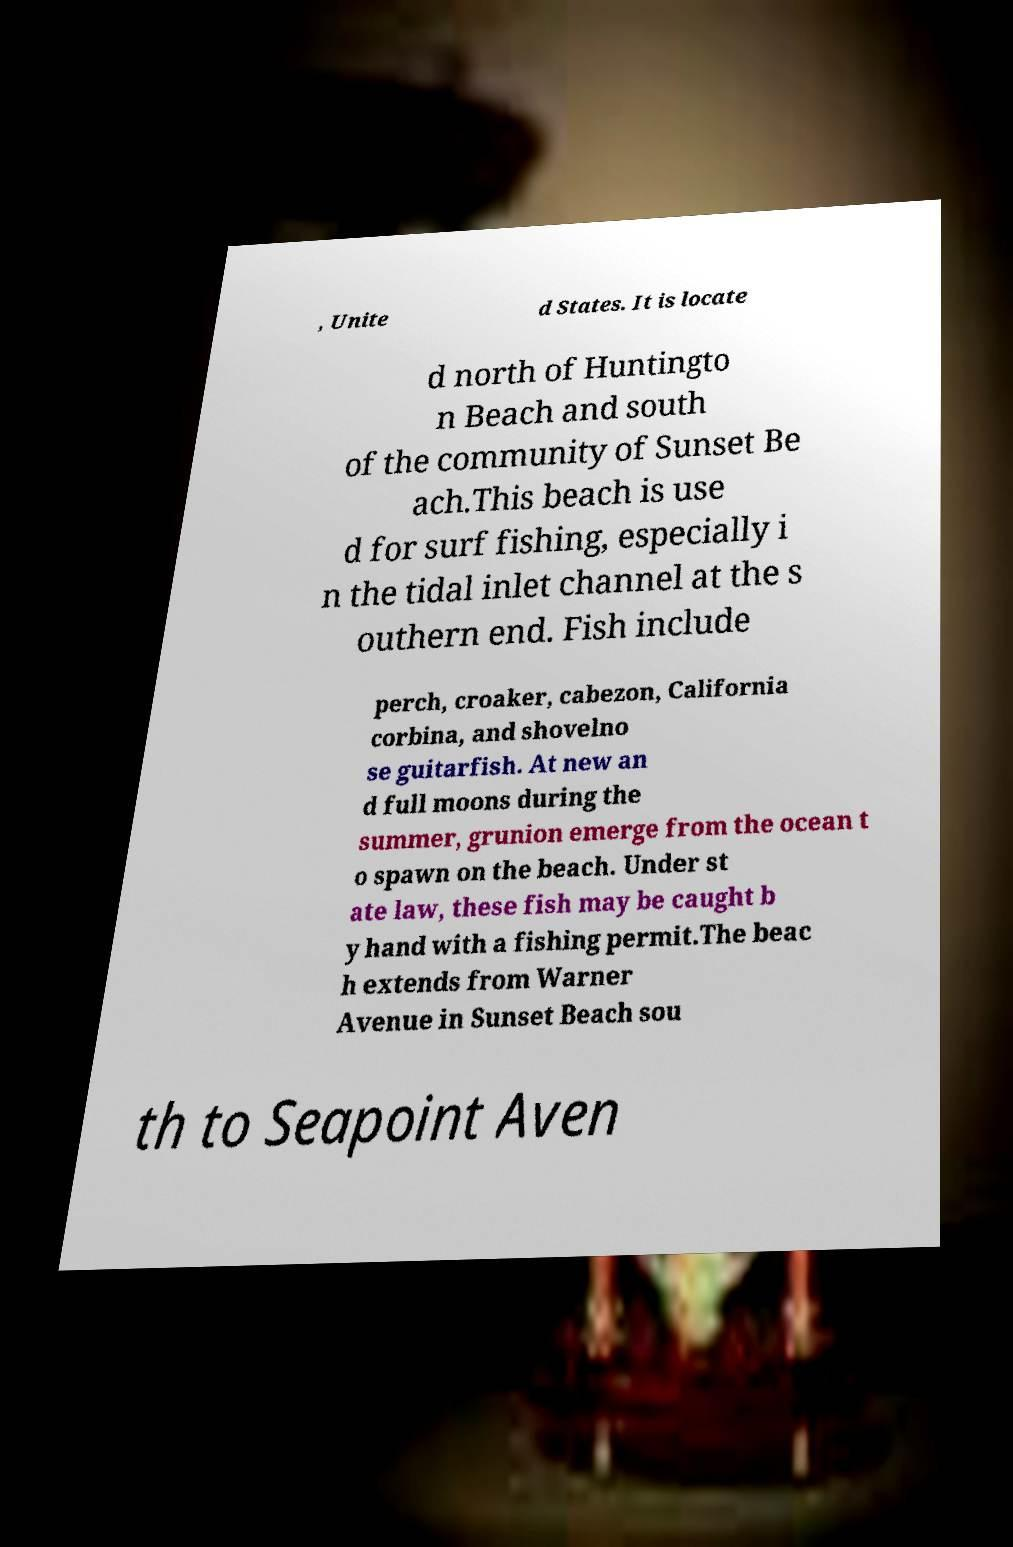There's text embedded in this image that I need extracted. Can you transcribe it verbatim? , Unite d States. It is locate d north of Huntingto n Beach and south of the community of Sunset Be ach.This beach is use d for surf fishing, especially i n the tidal inlet channel at the s outhern end. Fish include perch, croaker, cabezon, California corbina, and shovelno se guitarfish. At new an d full moons during the summer, grunion emerge from the ocean t o spawn on the beach. Under st ate law, these fish may be caught b y hand with a fishing permit.The beac h extends from Warner Avenue in Sunset Beach sou th to Seapoint Aven 